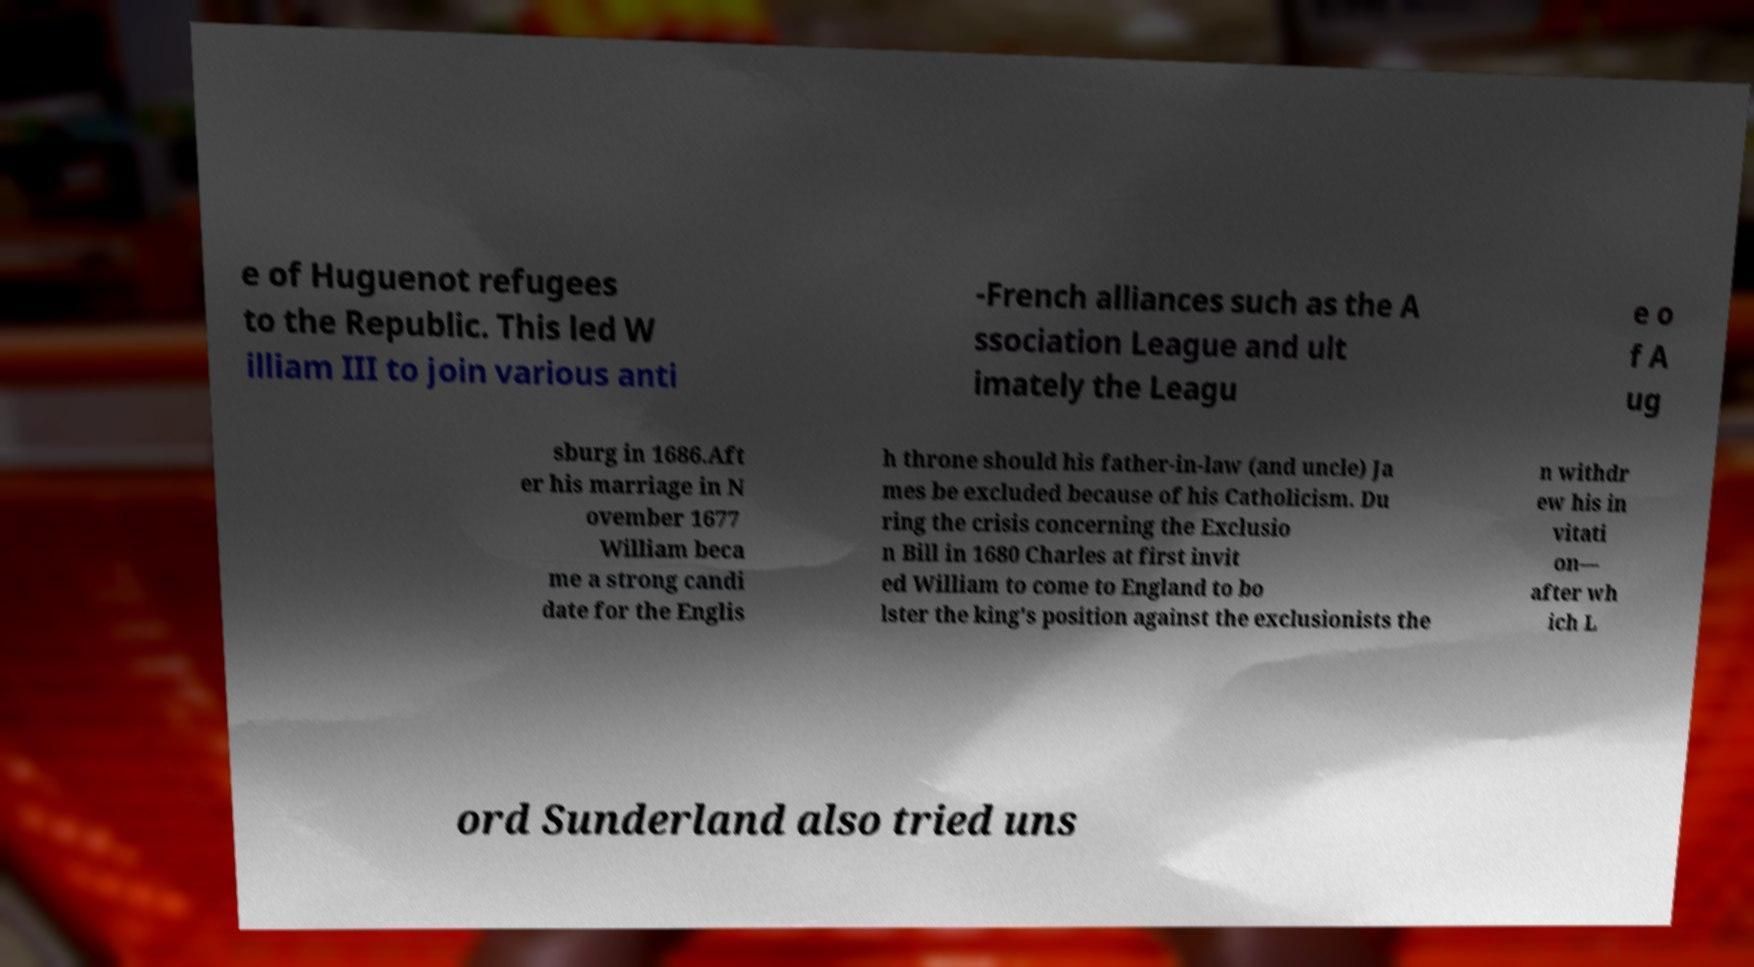Can you accurately transcribe the text from the provided image for me? e of Huguenot refugees to the Republic. This led W illiam III to join various anti -French alliances such as the A ssociation League and ult imately the Leagu e o f A ug sburg in 1686.Aft er his marriage in N ovember 1677 William beca me a strong candi date for the Englis h throne should his father-in-law (and uncle) Ja mes be excluded because of his Catholicism. Du ring the crisis concerning the Exclusio n Bill in 1680 Charles at first invit ed William to come to England to bo lster the king's position against the exclusionists the n withdr ew his in vitati on— after wh ich L ord Sunderland also tried uns 